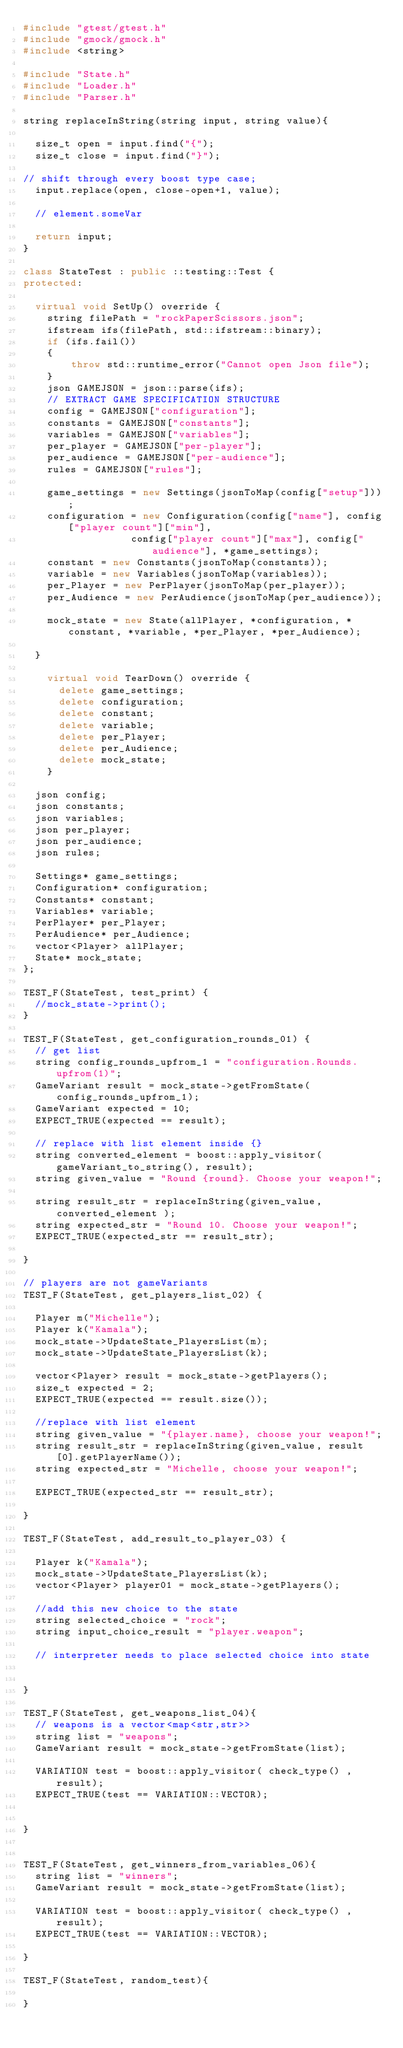<code> <loc_0><loc_0><loc_500><loc_500><_C++_>#include "gtest/gtest.h"
#include "gmock/gmock.h"
#include <string>

#include "State.h"
#include "Loader.h"
#include "Parser.h"

string replaceInString(string input, string value){

  size_t open = input.find("{");
  size_t close = input.find("}");

// shift through every boost type case;
  input.replace(open, close-open+1, value);

  // element.someVar

  return input;
}

class StateTest : public ::testing::Test {
protected:

  virtual void SetUp() override {
    string filePath = "rockPaperScissors.json";
    ifstream ifs(filePath, std::ifstream::binary);
    if (ifs.fail())
    {
        throw std::runtime_error("Cannot open Json file");
    }
    json GAMEJSON = json::parse(ifs);
    // EXTRACT GAME SPECIFICATION STRUCTURE
    config = GAMEJSON["configuration"];
    constants = GAMEJSON["constants"];
    variables = GAMEJSON["variables"];
    per_player = GAMEJSON["per-player"];
    per_audience = GAMEJSON["per-audience"];
    rules = GAMEJSON["rules"];

    game_settings = new Settings(jsonToMap(config["setup"]));
    configuration = new Configuration(config["name"], config["player count"]["min"],
                  config["player count"]["max"], config["audience"], *game_settings);
    constant = new Constants(jsonToMap(constants));
    variable = new Variables(jsonToMap(variables));
    per_Player = new PerPlayer(jsonToMap(per_player));
    per_Audience = new PerAudience(jsonToMap(per_audience));

    mock_state = new State(allPlayer, *configuration, *constant, *variable, *per_Player, *per_Audience);

  }

    virtual void TearDown() override {
      delete game_settings;
      delete configuration;
      delete constant;
      delete variable;
      delete per_Player;
      delete per_Audience;
      delete mock_state;
    }

  json config;
  json constants;
  json variables;
  json per_player;
  json per_audience;
  json rules;

  Settings* game_settings;
  Configuration* configuration;
  Constants* constant;
  Variables* variable;
  PerPlayer* per_Player;
  PerAudience* per_Audience;
  vector<Player> allPlayer;
  State* mock_state;
};

TEST_F(StateTest, test_print) {
  //mock_state->print();
}

TEST_F(StateTest, get_configuration_rounds_01) {
  // get list
  string config_rounds_upfrom_1 = "configuration.Rounds.upfrom(1)";
  GameVariant result = mock_state->getFromState(config_rounds_upfrom_1);
  GameVariant expected = 10;
  EXPECT_TRUE(expected == result);

  // replace with list element inside {}
  string converted_element = boost::apply_visitor( gameVariant_to_string(), result);
  string given_value = "Round {round}. Choose your weapon!";

  string result_str = replaceInString(given_value, converted_element );
  string expected_str = "Round 10. Choose your weapon!";
  EXPECT_TRUE(expected_str == result_str);

}

// players are not gameVariants
TEST_F(StateTest, get_players_list_02) {

  Player m("Michelle");
  Player k("Kamala");
  mock_state->UpdateState_PlayersList(m);
  mock_state->UpdateState_PlayersList(k);

  vector<Player> result = mock_state->getPlayers();
  size_t expected = 2;
  EXPECT_TRUE(expected == result.size());

  //replace with list element
  string given_value = "{player.name}, choose your weapon!";
  string result_str = replaceInString(given_value, result[0].getPlayerName());
  string expected_str = "Michelle, choose your weapon!";

  EXPECT_TRUE(expected_str == result_str);

}

TEST_F(StateTest, add_result_to_player_03) {

  Player k("Kamala");
  mock_state->UpdateState_PlayersList(k);
  vector<Player> player01 = mock_state->getPlayers();

  //add this new choice to the state
  string selected_choice = "rock";
  string input_choice_result = "player.weapon";

  // interpreter needs to place selected choice into state


}

TEST_F(StateTest, get_weapons_list_04){
  // weapons is a vector<map<str,str>>
  string list = "weapons";
  GameVariant result = mock_state->getFromState(list);

  VARIATION test = boost::apply_visitor( check_type() , result);
  EXPECT_TRUE(test == VARIATION::VECTOR);


}


TEST_F(StateTest, get_winners_from_variables_06){
  string list = "winners";
  GameVariant result = mock_state->getFromState(list);

  VARIATION test = boost::apply_visitor( check_type() , result);
  EXPECT_TRUE(test == VARIATION::VECTOR);

}

TEST_F(StateTest, random_test){

}
</code> 